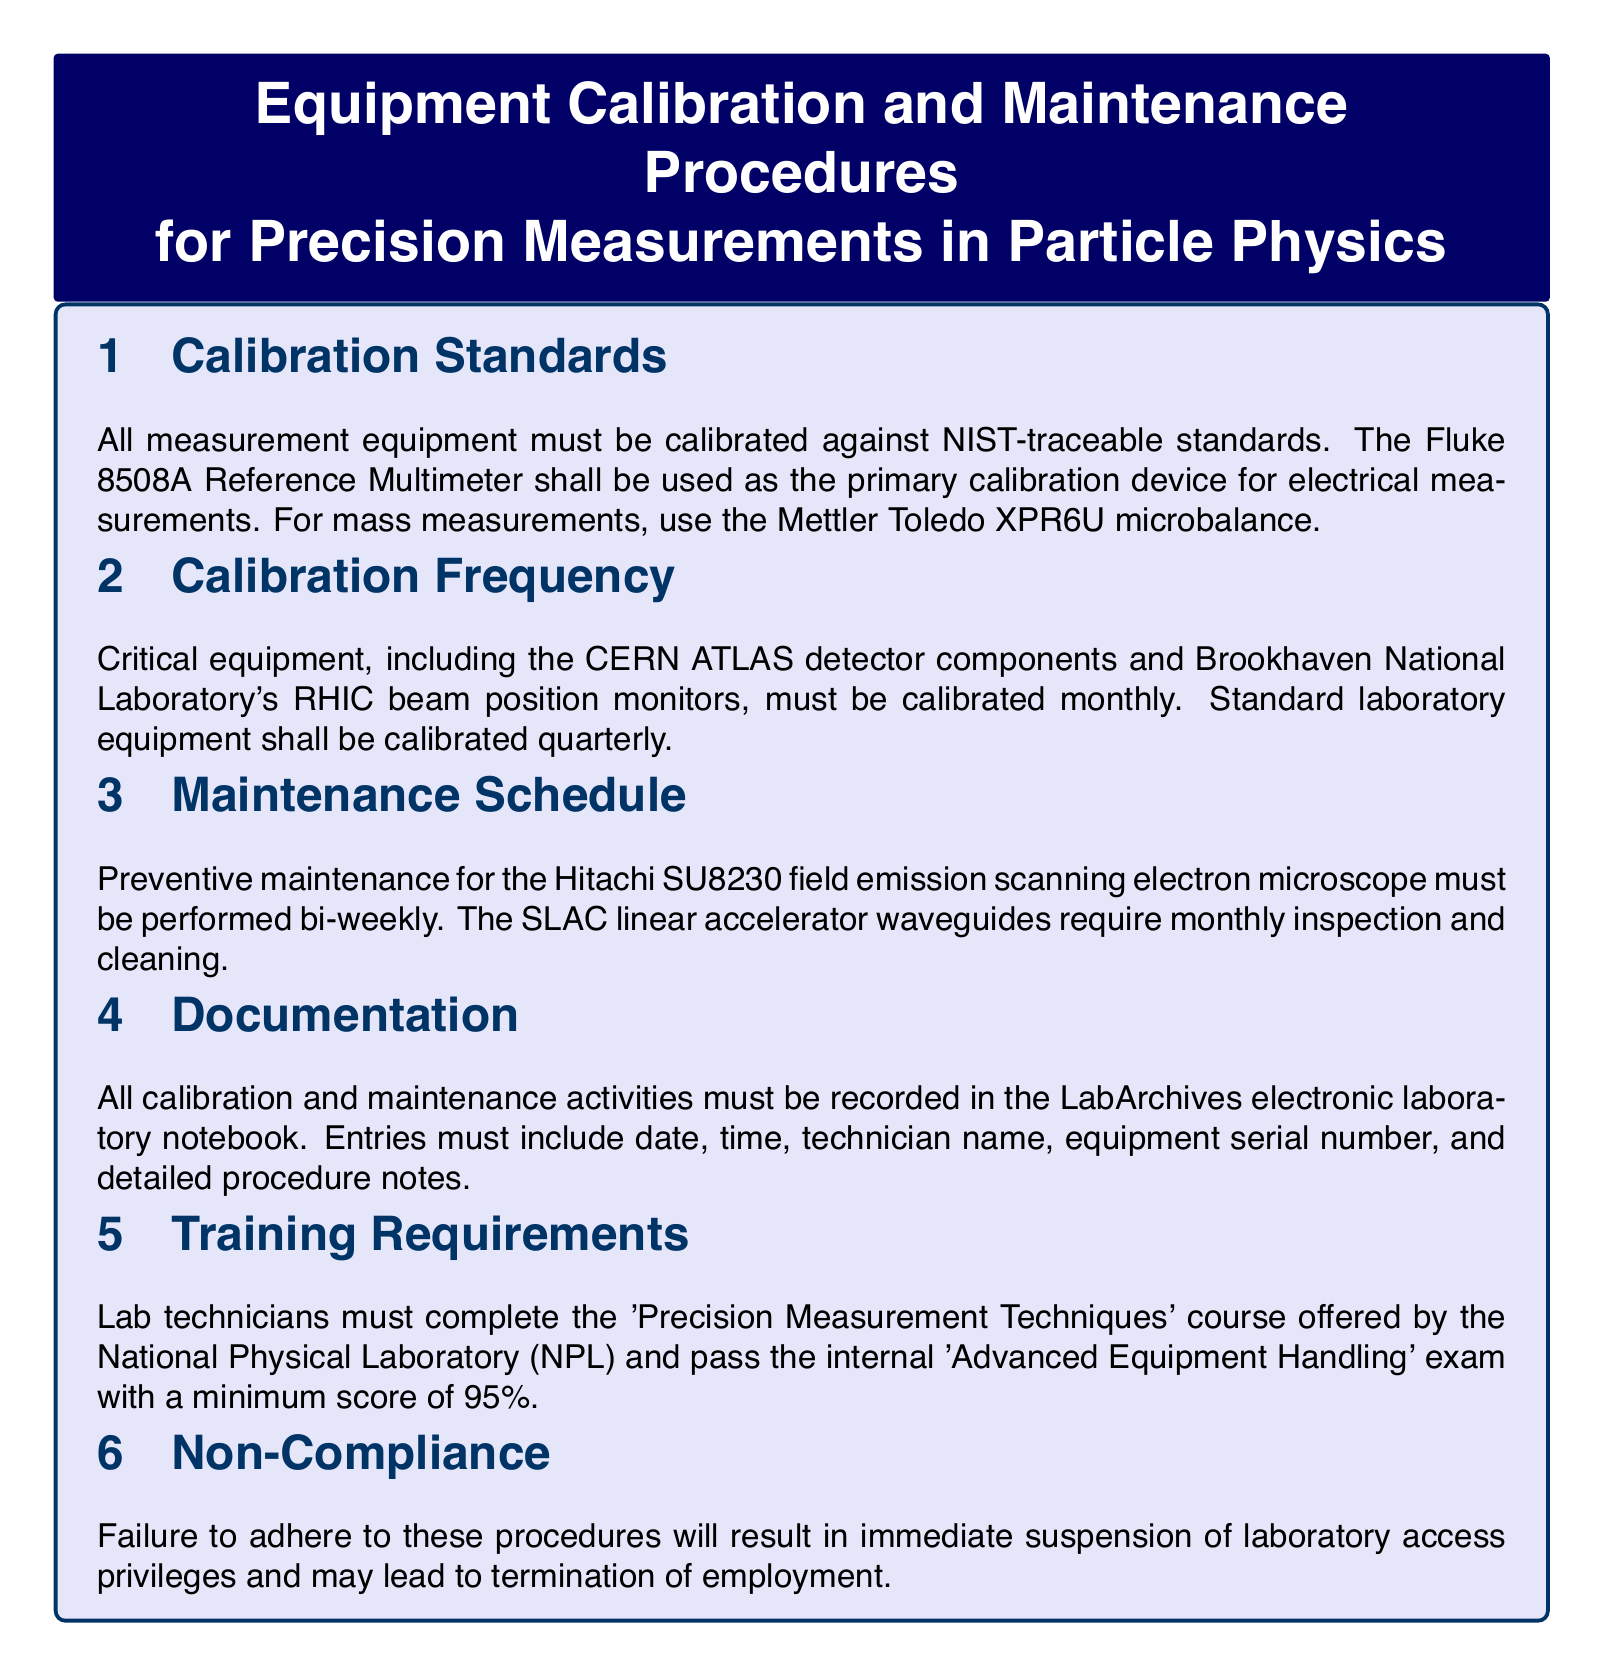What device is used for electrical measurements? The document specifies that the Fluke 8508A Reference Multimeter is the primary calibration device for electrical measurements.
Answer: Fluke 8508A Reference Multimeter How often must critical equipment be calibrated? The document states that critical equipment must be calibrated monthly.
Answer: Monthly What is the preventive maintenance schedule for the Hitachi SU8230? According to the document, preventive maintenance for the Hitachi SU8230 must be performed bi-weekly.
Answer: Bi-weekly What electronic notebook is used for documentation? The document mentions that LabArchives is the electronic laboratory notebook used for documentation.
Answer: LabArchives What score is required to pass the internal exam? The document indicates that a minimum score of 95% is required to pass the internal 'Advanced Equipment Handling' exam.
Answer: 95% Which organization offers the 'Precision Measurement Techniques' course? The document states that the National Physical Laboratory (NPL) offers the course.
Answer: National Physical Laboratory (NPL) What consequences are mentioned for non-compliance? The document outlines that failure to adhere to procedures may lead to immediate suspension of access privileges and possible termination of employment.
Answer: Suspension and termination How often are standard laboratory equipment calibrated? The document specifies that standard laboratory equipment shall be calibrated quarterly.
Answer: Quarterly What is the frequency of inspection for the SLAC linear accelerator waveguides? The document states that the SLAC linear accelerator waveguides require monthly inspection and cleaning.
Answer: Monthly 